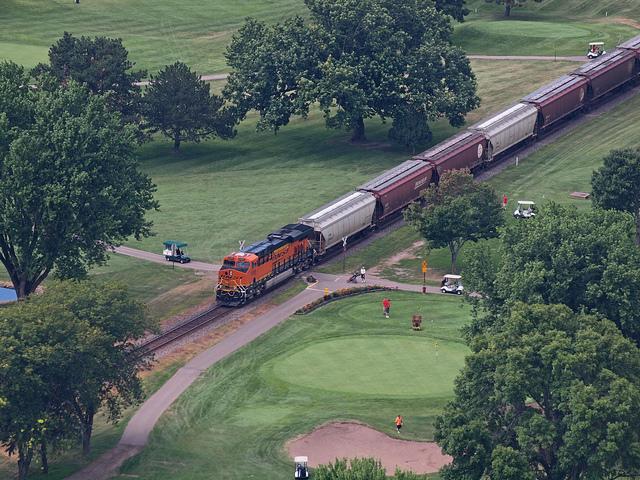How many train cars?
Give a very brief answer. 7. What activity are the people doing?
Short answer required. Golfing. How many people are shown?
Answer briefly. 5. 